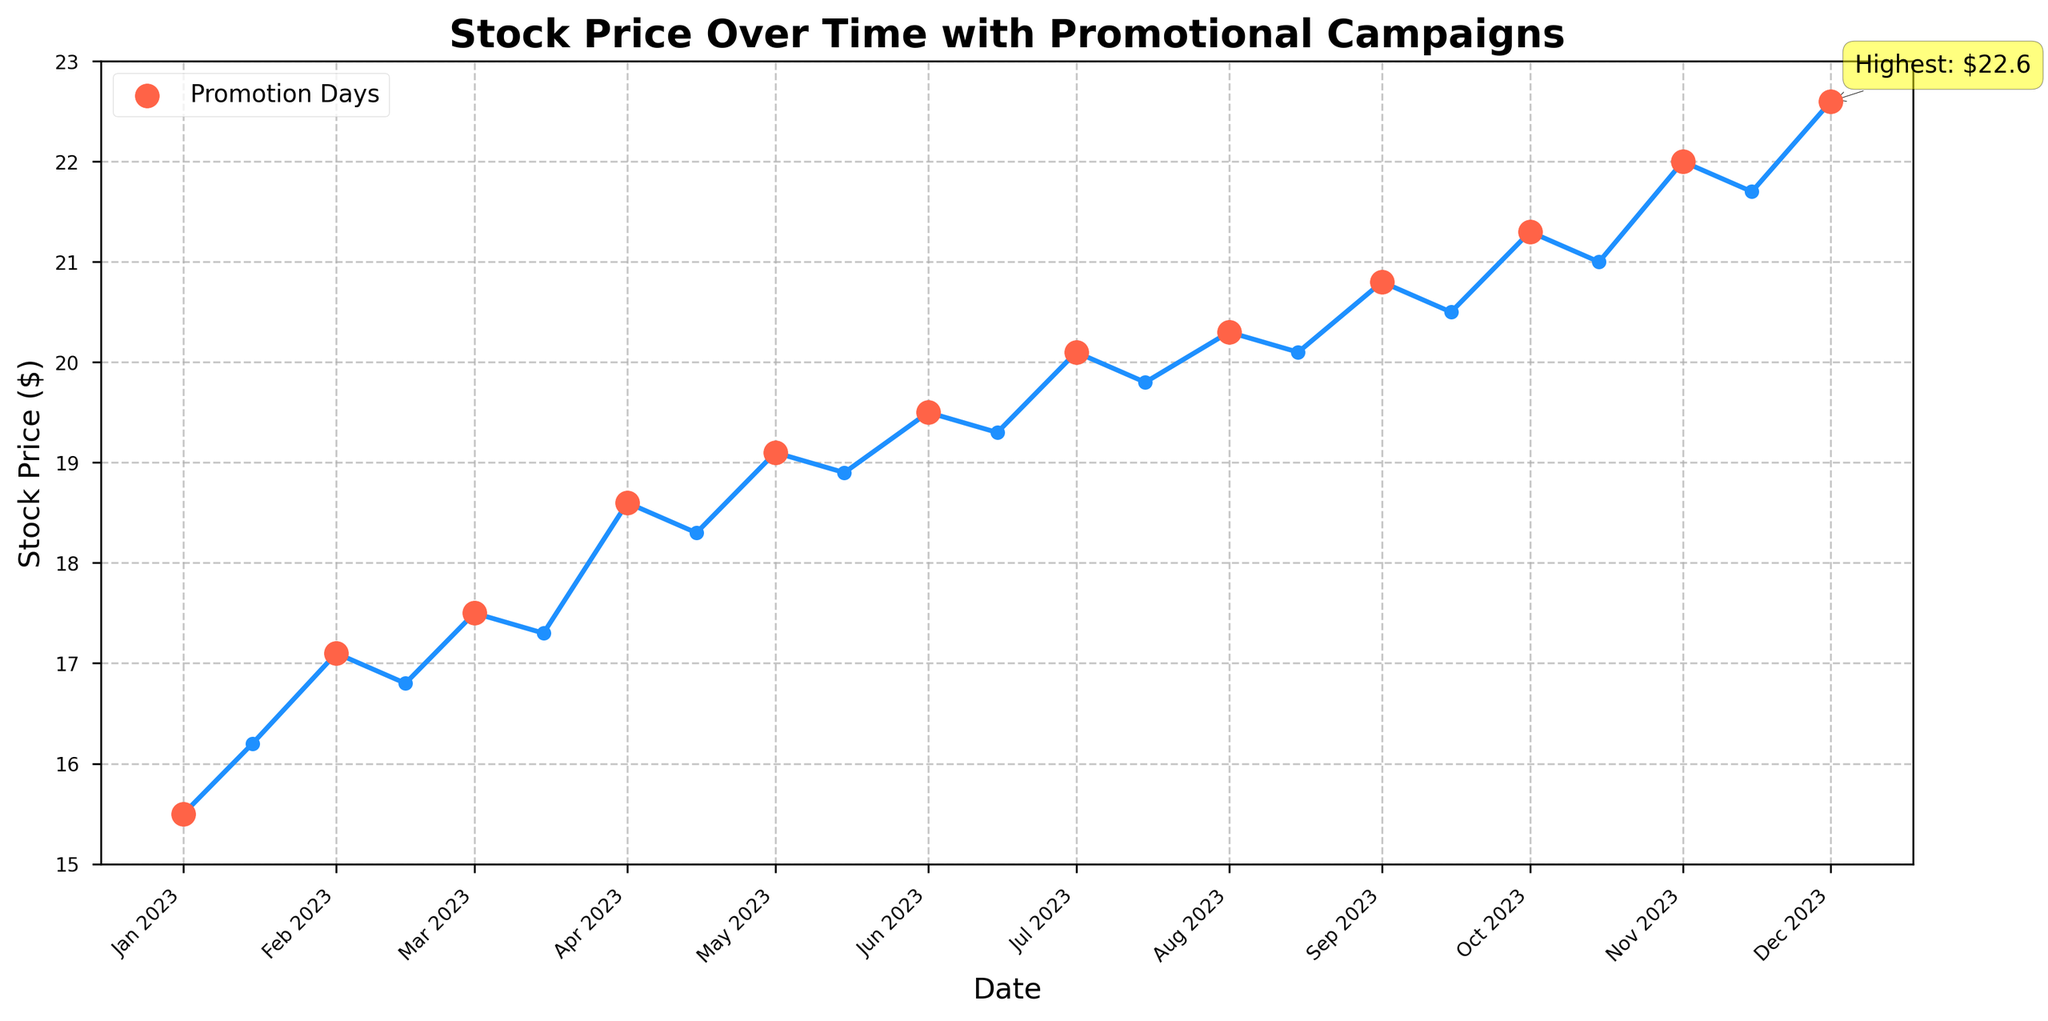What is the title of the plot? The title is at the top of the plot, usually representing the overall theme or subject of the data presented.
Answer: Stock Price Over Time with Promotional Campaigns How many promotional campaigns are highlighted in the plot? Promotional campaigns are marked with highlighted points on the plot. Count the number of these highlighted points to determine the number of campaigns.
Answer: 12 What is the highest stock price observed in the plot and on what date? Look for the point with the highest value on the y-axis (Stock Price) and check its corresponding date on the x-axis. The highest price is specially annotated in the plot.
Answer: $22.6 on December 1, 2023 Which promotional campaign is associated with the highest stock price? Identify the promotional campaign that corresponds to the date of the highest stock price. This information is usually labeled near or on the highlighted point.
Answer: Holiday Season Sale on December 1, 2023 What is the general trend of the stock price over the time period shown? Observe the overall direction of the stock price data points from the start to the end of the time period. Is it generally increasing, decreasing, or fluctuating?
Answer: Generally increasing On average, how much did the stock price increase after each promotional campaign? Calculate the stock price difference after each campaign and average them. Find differences by subtracting the price before the campaign from the price after the campaign for each case, then take the mean of these differences.
Answer: Average increase of $0.73 During which promotional campaign did the stock price increase the most? Compare stock price differences before and after each promotional campaign. The campaign with the largest positive difference has the most significant increase.
Answer: Black Friday Sale How does the stock price at the start of the year compare to the stock price at the end of the year? Subtract the stock price at the beginning (January 1) from the stock price at the end (December 1).
Answer: Increased by $7.1 Which promotional campaign had the least impact on the stock price? Look for the smallest change in stock price before and after each promotion and find the corresponding campaign.
Answer: Valentine's Day Special Is there a pattern between promotional campaigns and stock price changes? Review stock price changes around promotional campaigns to determine if there is a consistent pattern of increase/decrease following promotions.
Answer: Stock prices generally increase after promotional campaigns 